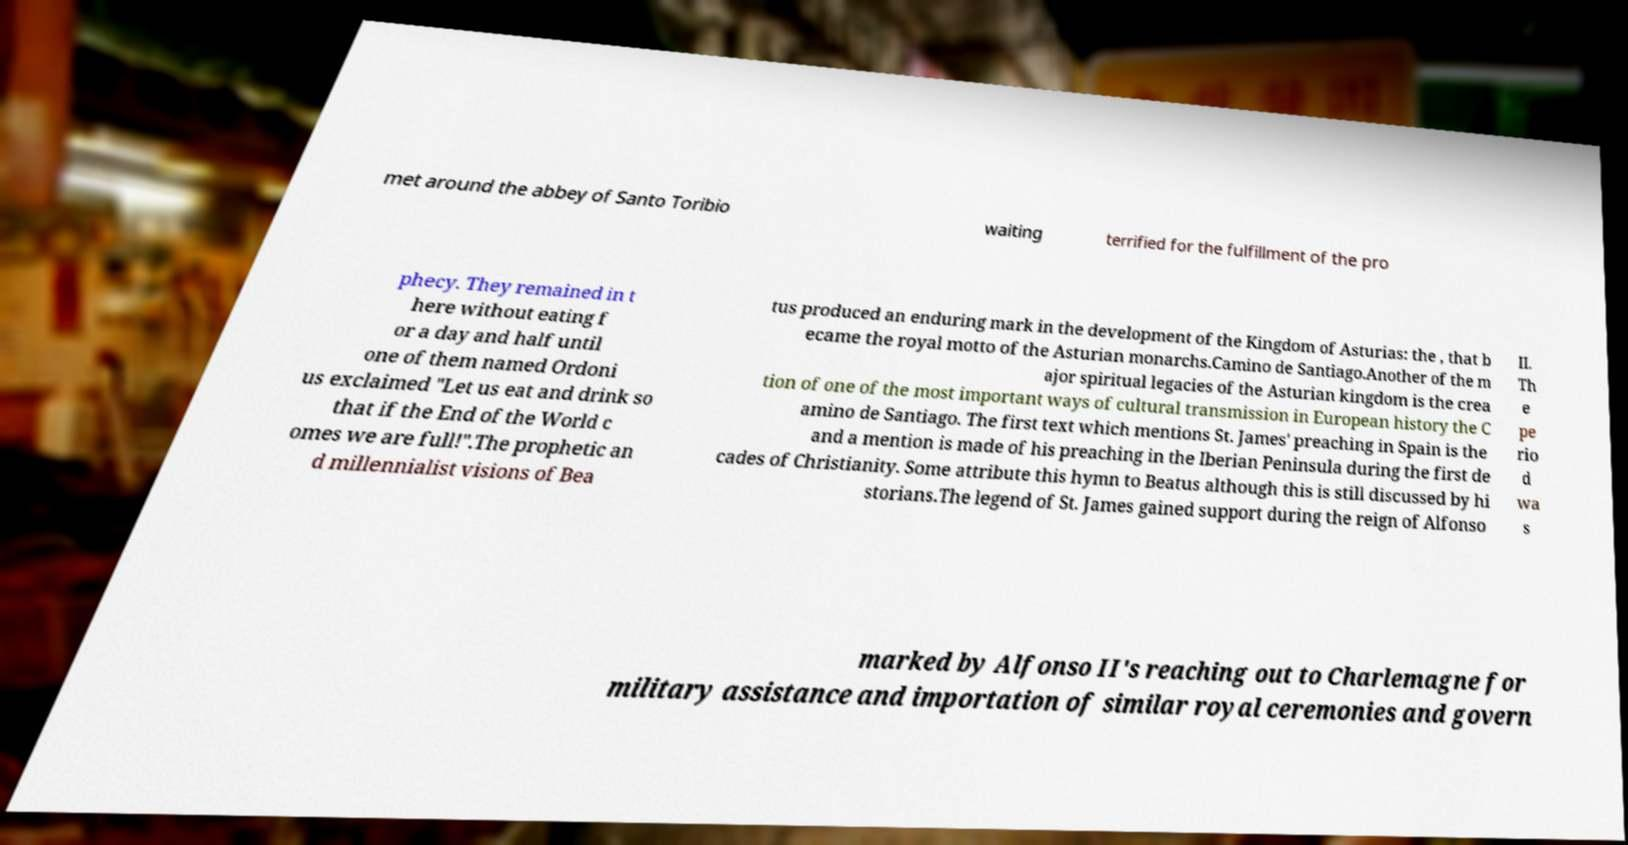For documentation purposes, I need the text within this image transcribed. Could you provide that? met around the abbey of Santo Toribio waiting terrified for the fulfillment of the pro phecy. They remained in t here without eating f or a day and half until one of them named Ordoni us exclaimed "Let us eat and drink so that if the End of the World c omes we are full!".The prophetic an d millennialist visions of Bea tus produced an enduring mark in the development of the Kingdom of Asturias: the , that b ecame the royal motto of the Asturian monarchs.Camino de Santiago.Another of the m ajor spiritual legacies of the Asturian kingdom is the crea tion of one of the most important ways of cultural transmission in European history the C amino de Santiago. The first text which mentions St. James' preaching in Spain is the and a mention is made of his preaching in the Iberian Peninsula during the first de cades of Christianity. Some attribute this hymn to Beatus although this is still discussed by hi storians.The legend of St. James gained support during the reign of Alfonso II. Th e pe rio d wa s marked by Alfonso II's reaching out to Charlemagne for military assistance and importation of similar royal ceremonies and govern 